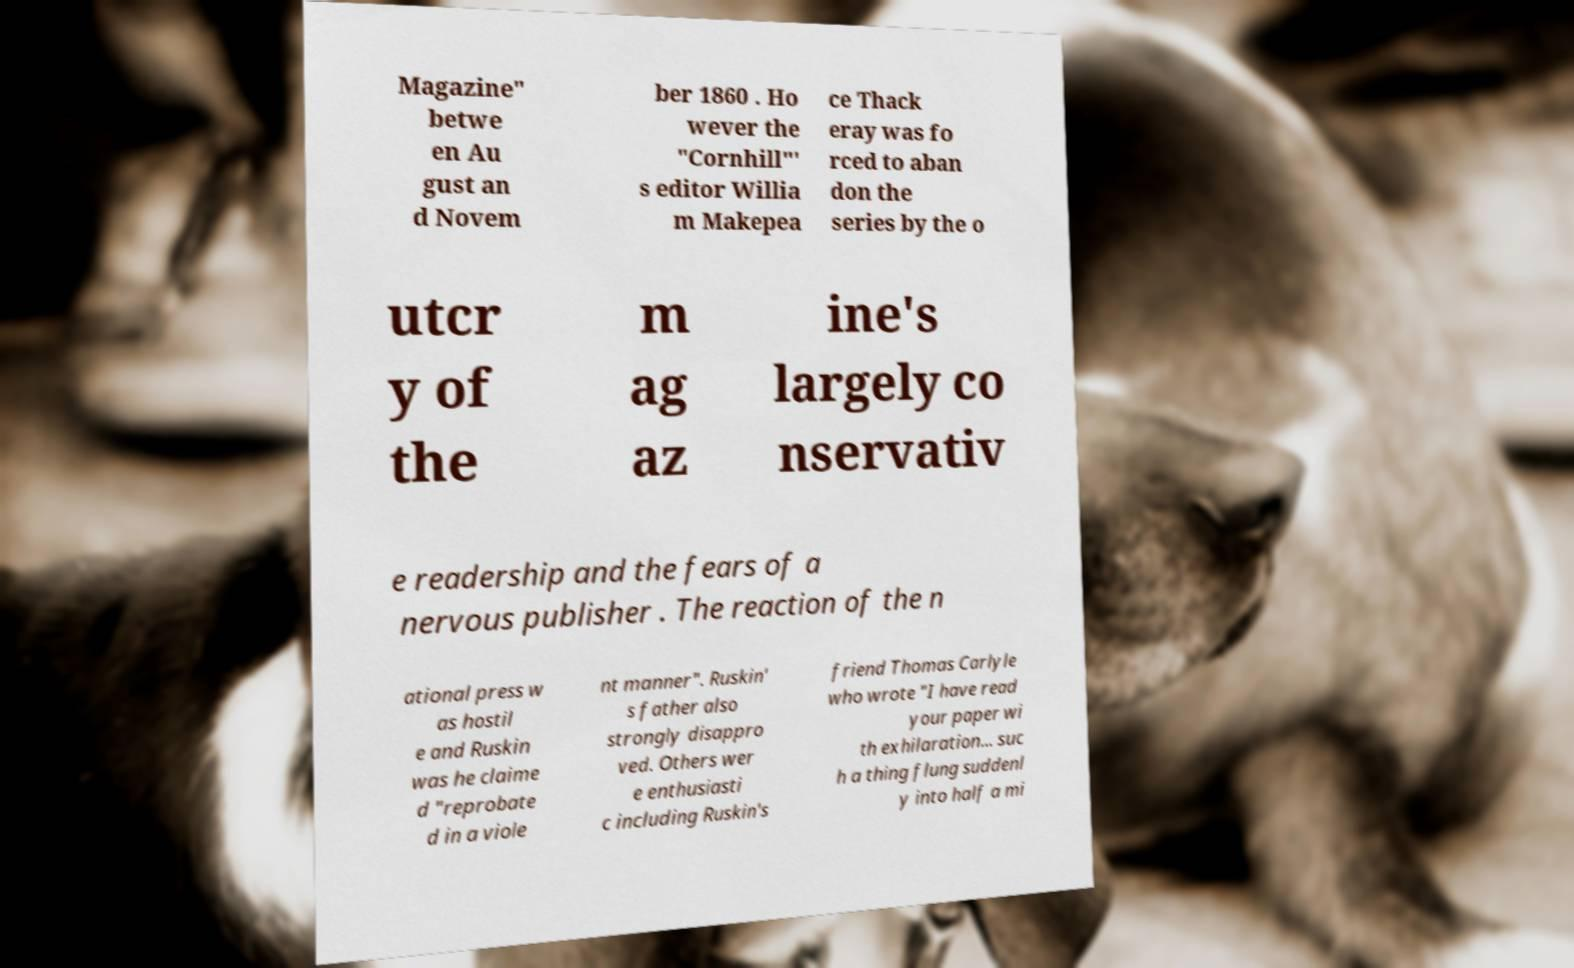Please read and relay the text visible in this image. What does it say? Magazine" betwe en Au gust an d Novem ber 1860 . Ho wever the "Cornhill"' s editor Willia m Makepea ce Thack eray was fo rced to aban don the series by the o utcr y of the m ag az ine's largely co nservativ e readership and the fears of a nervous publisher . The reaction of the n ational press w as hostil e and Ruskin was he claime d "reprobate d in a viole nt manner". Ruskin' s father also strongly disappro ved. Others wer e enthusiasti c including Ruskin's friend Thomas Carlyle who wrote "I have read your paper wi th exhilaration... suc h a thing flung suddenl y into half a mi 